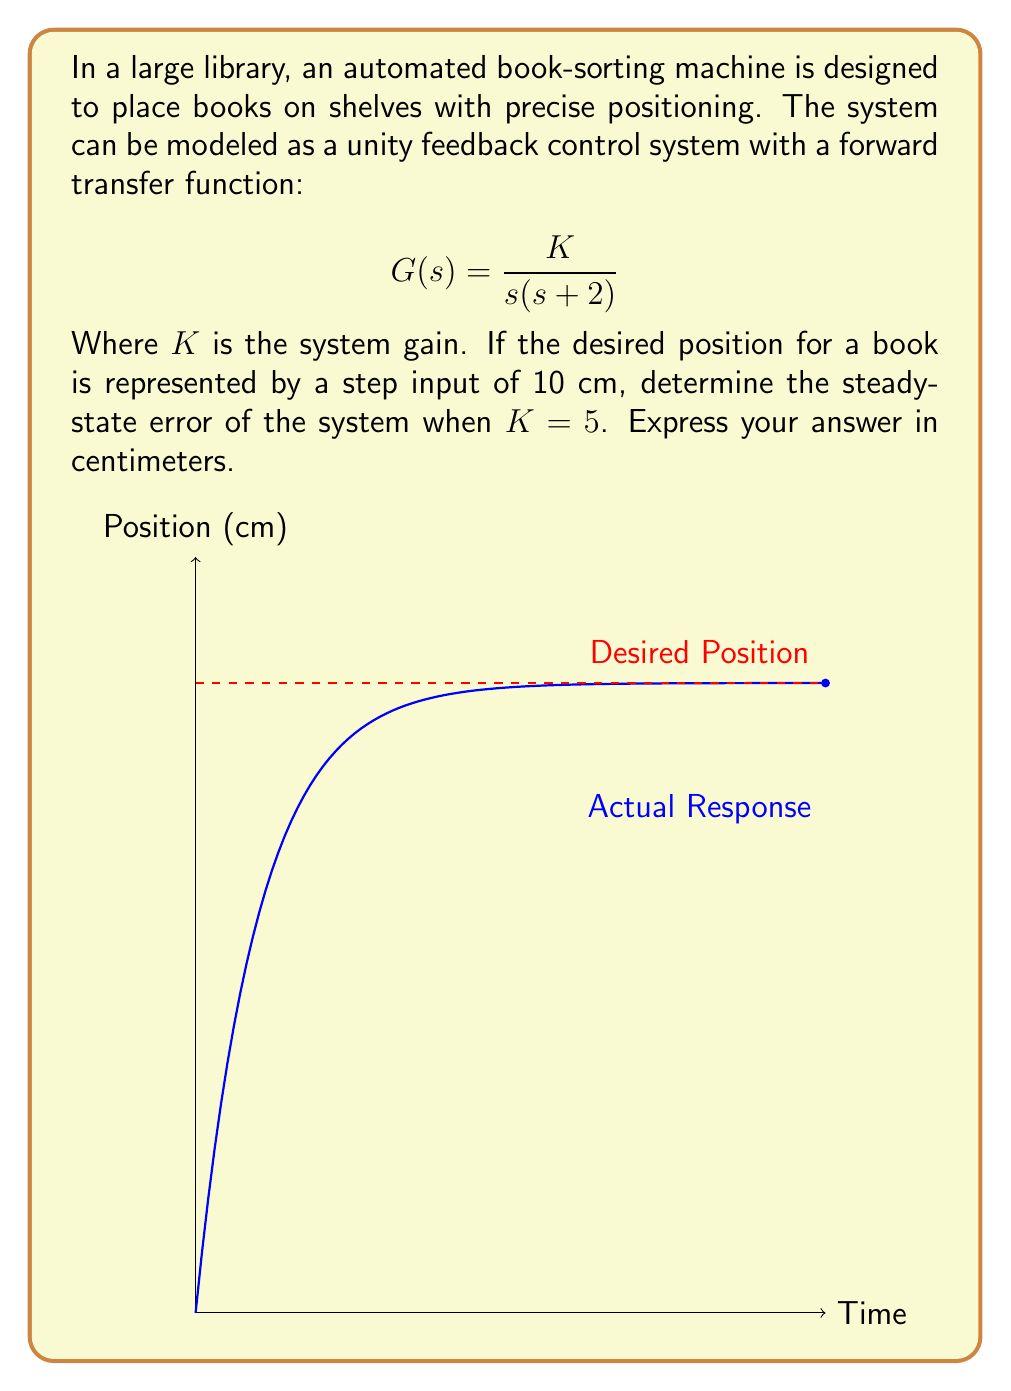Can you answer this question? Let's approach this step-by-step:

1) The steady-state error for a position control system (Type 1 system) with a step input is given by:

   $$e_{ss} = \frac{1}{1 + K_p}R$$

   Where $K_p$ is the position error constant and $R$ is the magnitude of the step input.

2) To find $K_p$, we need to evaluate:

   $$K_p = \lim_{s \to 0} sG(s)$$

3) Substituting our transfer function:

   $$K_p = \lim_{s \to 0} s \cdot \frac{K}{s(s + 2)} = \lim_{s \to 0} \frac{K}{s + 2} = \frac{K}{2}$$

4) Given $K = 5$, we can calculate $K_p$:

   $$K_p = \frac{5}{2} = 2.5$$

5) Now we can calculate the steady-state error:

   $$e_{ss} = \frac{1}{1 + K_p}R = \frac{1}{1 + 2.5} \cdot 10 \text{ cm} = \frac{10}{3.5} \text{ cm} \approx 2.86 \text{ cm}$$

This means the book-sorting machine will consistently place books about 2.86 cm away from their desired position in steady-state.
Answer: 2.86 cm 